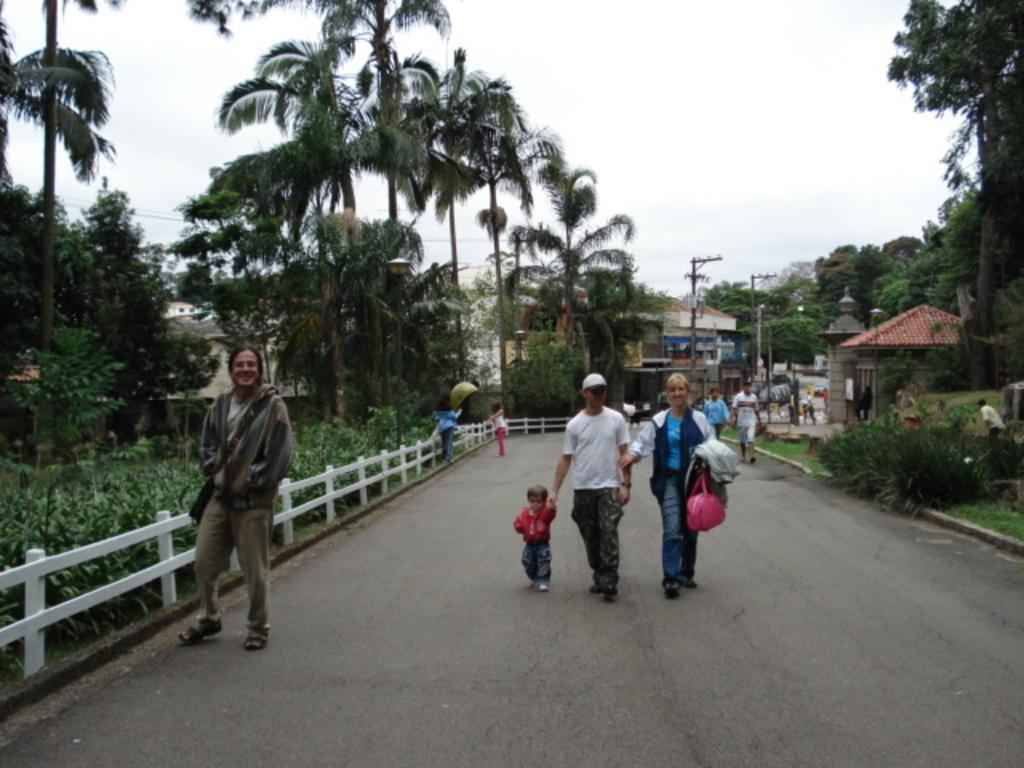What can be seen on the road in the image? There are people on the road in the image. What type of natural elements are present in the image? There are trees and plants in the image. What type of man-made structures can be seen in the image? There are buildings in the image. What type of infrastructure elements are present in the image? There are electric poles and cables in the image. What part of the natural environment is visible in the image? The sky is visible in the image. What type of love can be seen between the trees in the image? There is no love present between the trees in the image; they are inanimate objects. What type of voyage are the people on the road embarking on in the image? There is no indication of a voyage in the image; it simply shows people on the road. 